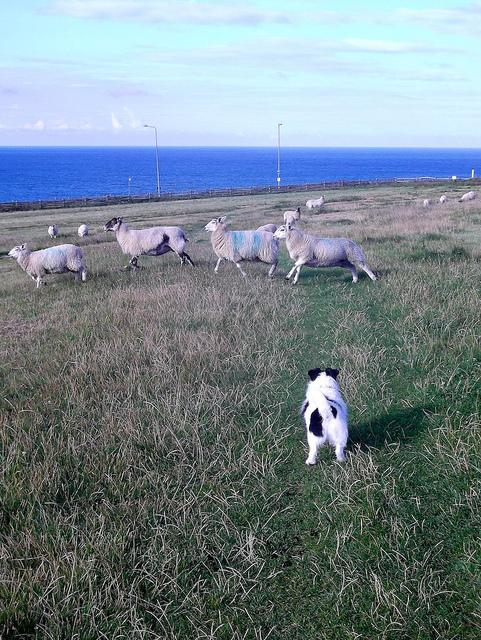What are the blue marks from?

Choices:
A) paint
B) crayon
C) chalk
D) oil paint 